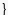<code> <loc_0><loc_0><loc_500><loc_500><_Java_>}
</code> 